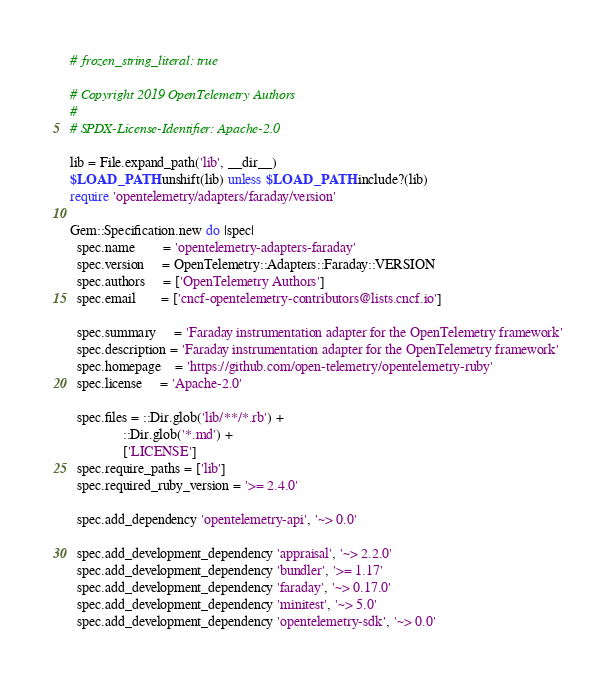<code> <loc_0><loc_0><loc_500><loc_500><_Ruby_># frozen_string_literal: true

# Copyright 2019 OpenTelemetry Authors
#
# SPDX-License-Identifier: Apache-2.0

lib = File.expand_path('lib', __dir__)
$LOAD_PATH.unshift(lib) unless $LOAD_PATH.include?(lib)
require 'opentelemetry/adapters/faraday/version'

Gem::Specification.new do |spec|
  spec.name        = 'opentelemetry-adapters-faraday'
  spec.version     = OpenTelemetry::Adapters::Faraday::VERSION
  spec.authors     = ['OpenTelemetry Authors']
  spec.email       = ['cncf-opentelemetry-contributors@lists.cncf.io']

  spec.summary     = 'Faraday instrumentation adapter for the OpenTelemetry framework'
  spec.description = 'Faraday instrumentation adapter for the OpenTelemetry framework'
  spec.homepage    = 'https://github.com/open-telemetry/opentelemetry-ruby'
  spec.license     = 'Apache-2.0'

  spec.files = ::Dir.glob('lib/**/*.rb') +
               ::Dir.glob('*.md') +
               ['LICENSE']
  spec.require_paths = ['lib']
  spec.required_ruby_version = '>= 2.4.0'

  spec.add_dependency 'opentelemetry-api', '~> 0.0'

  spec.add_development_dependency 'appraisal', '~> 2.2.0'
  spec.add_development_dependency 'bundler', '>= 1.17'
  spec.add_development_dependency 'faraday', '~> 0.17.0'
  spec.add_development_dependency 'minitest', '~> 5.0'
  spec.add_development_dependency 'opentelemetry-sdk', '~> 0.0'</code> 